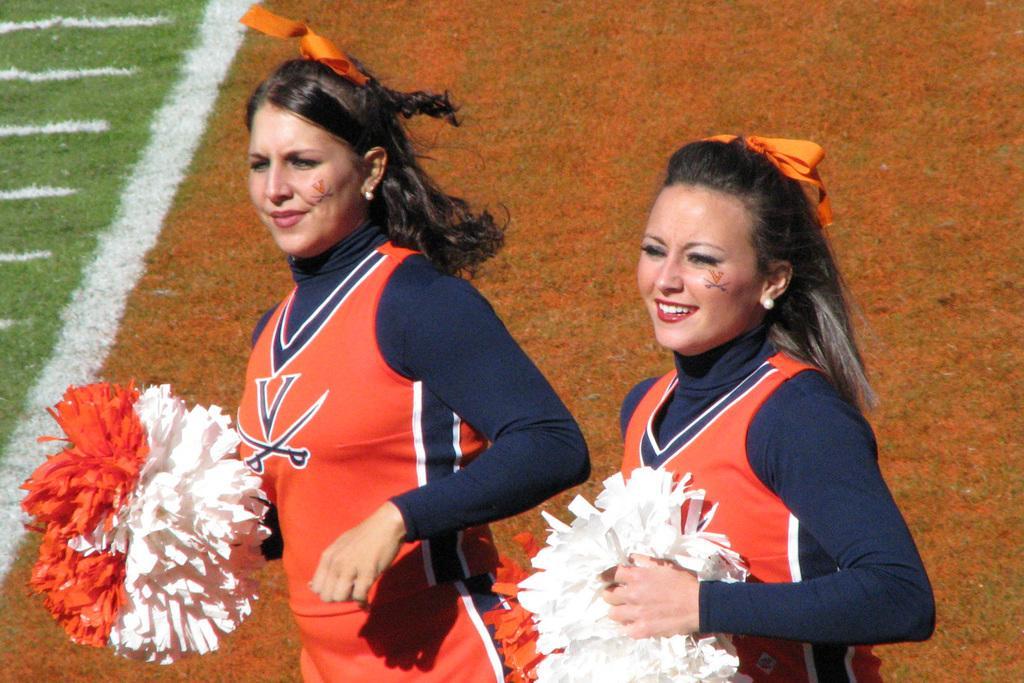Please provide a concise description of this image. In this image there are 2 beautiful girls, they wore orange color t-shirts and holding white and orange color flowers made up of paper. 